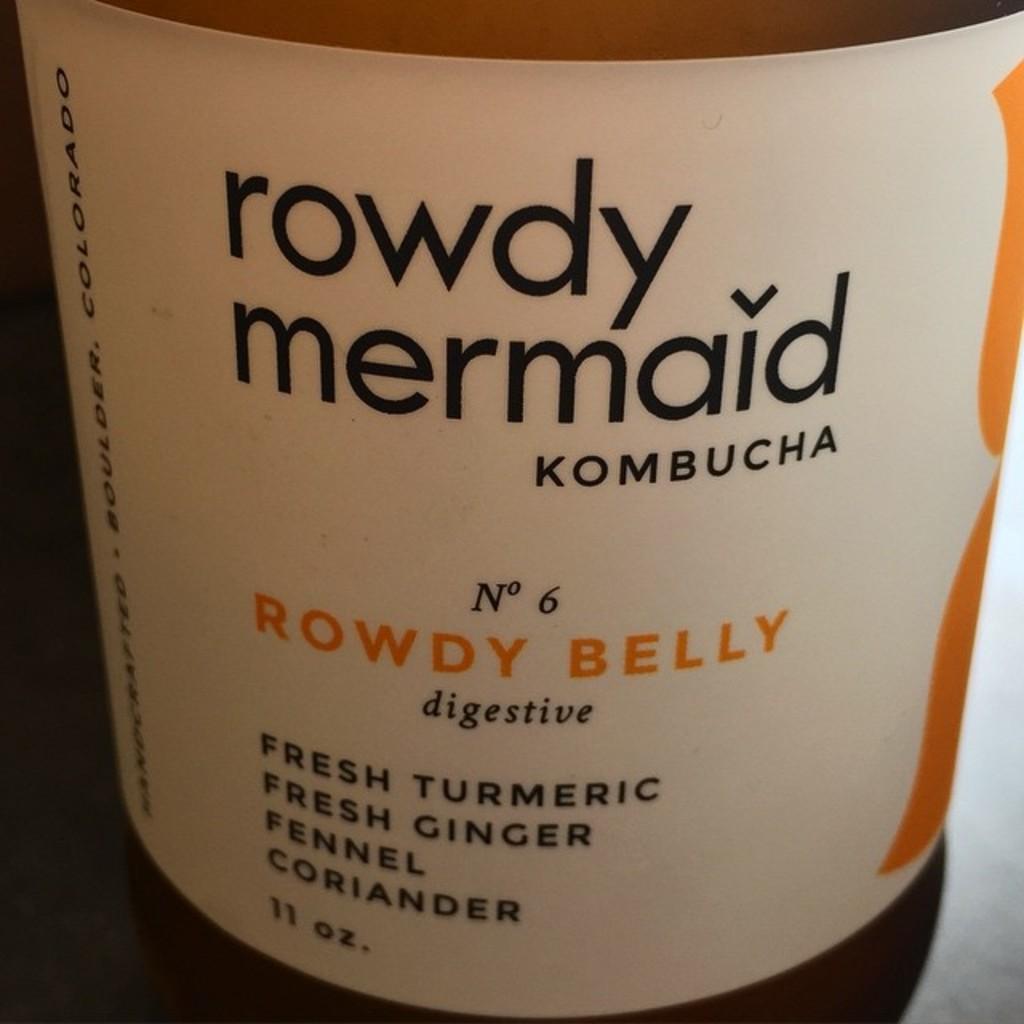What is the name on the bottle?
Your answer should be compact. Rowdy mermaid. What is the volume of this drink?
Make the answer very short. 11 oz. 